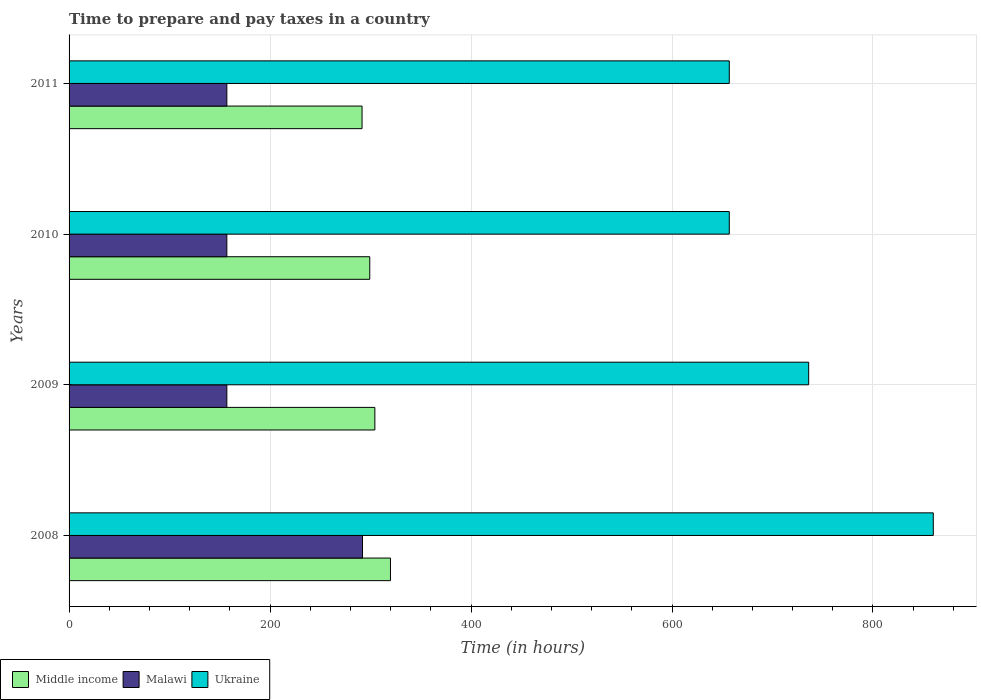Are the number of bars per tick equal to the number of legend labels?
Offer a terse response. Yes. Are the number of bars on each tick of the Y-axis equal?
Your answer should be compact. Yes. How many bars are there on the 3rd tick from the top?
Provide a succinct answer. 3. How many bars are there on the 4th tick from the bottom?
Your answer should be very brief. 3. In how many cases, is the number of bars for a given year not equal to the number of legend labels?
Give a very brief answer. 0. What is the number of hours required to prepare and pay taxes in Middle income in 2011?
Your answer should be very brief. 291.56. Across all years, what is the maximum number of hours required to prepare and pay taxes in Ukraine?
Offer a very short reply. 860. Across all years, what is the minimum number of hours required to prepare and pay taxes in Malawi?
Provide a succinct answer. 157. In which year was the number of hours required to prepare and pay taxes in Middle income minimum?
Offer a terse response. 2011. What is the total number of hours required to prepare and pay taxes in Ukraine in the graph?
Your answer should be compact. 2910. What is the difference between the number of hours required to prepare and pay taxes in Ukraine in 2008 and that in 2011?
Keep it short and to the point. 203. What is the difference between the number of hours required to prepare and pay taxes in Ukraine in 2009 and the number of hours required to prepare and pay taxes in Middle income in 2008?
Provide a succinct answer. 416.17. What is the average number of hours required to prepare and pay taxes in Middle income per year?
Your answer should be compact. 303.73. In the year 2008, what is the difference between the number of hours required to prepare and pay taxes in Middle income and number of hours required to prepare and pay taxes in Ukraine?
Offer a terse response. -540.17. What is the ratio of the number of hours required to prepare and pay taxes in Malawi in 2010 to that in 2011?
Offer a terse response. 1. Is the number of hours required to prepare and pay taxes in Middle income in 2008 less than that in 2011?
Your answer should be compact. No. What is the difference between the highest and the second highest number of hours required to prepare and pay taxes in Malawi?
Your answer should be compact. 135. What is the difference between the highest and the lowest number of hours required to prepare and pay taxes in Middle income?
Your answer should be compact. 28.28. In how many years, is the number of hours required to prepare and pay taxes in Middle income greater than the average number of hours required to prepare and pay taxes in Middle income taken over all years?
Offer a terse response. 2. Is the sum of the number of hours required to prepare and pay taxes in Malawi in 2008 and 2010 greater than the maximum number of hours required to prepare and pay taxes in Middle income across all years?
Make the answer very short. Yes. What does the 1st bar from the top in 2011 represents?
Provide a short and direct response. Ukraine. What does the 3rd bar from the bottom in 2008 represents?
Offer a terse response. Ukraine. Is it the case that in every year, the sum of the number of hours required to prepare and pay taxes in Middle income and number of hours required to prepare and pay taxes in Malawi is greater than the number of hours required to prepare and pay taxes in Ukraine?
Keep it short and to the point. No. How many years are there in the graph?
Offer a very short reply. 4. Are the values on the major ticks of X-axis written in scientific E-notation?
Your answer should be very brief. No. Does the graph contain any zero values?
Your answer should be compact. No. What is the title of the graph?
Ensure brevity in your answer.  Time to prepare and pay taxes in a country. What is the label or title of the X-axis?
Your response must be concise. Time (in hours). What is the Time (in hours) of Middle income in 2008?
Provide a succinct answer. 319.83. What is the Time (in hours) in Malawi in 2008?
Give a very brief answer. 292. What is the Time (in hours) of Ukraine in 2008?
Provide a short and direct response. 860. What is the Time (in hours) in Middle income in 2009?
Your answer should be compact. 304.31. What is the Time (in hours) of Malawi in 2009?
Offer a terse response. 157. What is the Time (in hours) in Ukraine in 2009?
Your response must be concise. 736. What is the Time (in hours) of Middle income in 2010?
Your answer should be very brief. 299.24. What is the Time (in hours) in Malawi in 2010?
Your answer should be very brief. 157. What is the Time (in hours) of Ukraine in 2010?
Provide a short and direct response. 657. What is the Time (in hours) of Middle income in 2011?
Provide a short and direct response. 291.56. What is the Time (in hours) of Malawi in 2011?
Keep it short and to the point. 157. What is the Time (in hours) in Ukraine in 2011?
Make the answer very short. 657. Across all years, what is the maximum Time (in hours) in Middle income?
Your response must be concise. 319.83. Across all years, what is the maximum Time (in hours) in Malawi?
Make the answer very short. 292. Across all years, what is the maximum Time (in hours) of Ukraine?
Give a very brief answer. 860. Across all years, what is the minimum Time (in hours) of Middle income?
Your answer should be very brief. 291.56. Across all years, what is the minimum Time (in hours) of Malawi?
Your answer should be compact. 157. Across all years, what is the minimum Time (in hours) of Ukraine?
Offer a terse response. 657. What is the total Time (in hours) of Middle income in the graph?
Your answer should be compact. 1214.93. What is the total Time (in hours) of Malawi in the graph?
Your response must be concise. 763. What is the total Time (in hours) of Ukraine in the graph?
Provide a short and direct response. 2910. What is the difference between the Time (in hours) of Middle income in 2008 and that in 2009?
Provide a short and direct response. 15.53. What is the difference between the Time (in hours) of Malawi in 2008 and that in 2009?
Offer a very short reply. 135. What is the difference between the Time (in hours) of Ukraine in 2008 and that in 2009?
Your response must be concise. 124. What is the difference between the Time (in hours) in Middle income in 2008 and that in 2010?
Your answer should be very brief. 20.59. What is the difference between the Time (in hours) of Malawi in 2008 and that in 2010?
Ensure brevity in your answer.  135. What is the difference between the Time (in hours) of Ukraine in 2008 and that in 2010?
Offer a very short reply. 203. What is the difference between the Time (in hours) in Middle income in 2008 and that in 2011?
Your answer should be very brief. 28.28. What is the difference between the Time (in hours) of Malawi in 2008 and that in 2011?
Your answer should be compact. 135. What is the difference between the Time (in hours) in Ukraine in 2008 and that in 2011?
Offer a very short reply. 203. What is the difference between the Time (in hours) of Middle income in 2009 and that in 2010?
Offer a very short reply. 5.07. What is the difference between the Time (in hours) of Ukraine in 2009 and that in 2010?
Provide a succinct answer. 79. What is the difference between the Time (in hours) of Middle income in 2009 and that in 2011?
Ensure brevity in your answer.  12.75. What is the difference between the Time (in hours) in Malawi in 2009 and that in 2011?
Ensure brevity in your answer.  0. What is the difference between the Time (in hours) in Ukraine in 2009 and that in 2011?
Provide a short and direct response. 79. What is the difference between the Time (in hours) in Middle income in 2010 and that in 2011?
Give a very brief answer. 7.68. What is the difference between the Time (in hours) of Middle income in 2008 and the Time (in hours) of Malawi in 2009?
Give a very brief answer. 162.83. What is the difference between the Time (in hours) in Middle income in 2008 and the Time (in hours) in Ukraine in 2009?
Provide a succinct answer. -416.17. What is the difference between the Time (in hours) of Malawi in 2008 and the Time (in hours) of Ukraine in 2009?
Provide a succinct answer. -444. What is the difference between the Time (in hours) of Middle income in 2008 and the Time (in hours) of Malawi in 2010?
Offer a very short reply. 162.83. What is the difference between the Time (in hours) in Middle income in 2008 and the Time (in hours) in Ukraine in 2010?
Your answer should be compact. -337.17. What is the difference between the Time (in hours) of Malawi in 2008 and the Time (in hours) of Ukraine in 2010?
Offer a very short reply. -365. What is the difference between the Time (in hours) of Middle income in 2008 and the Time (in hours) of Malawi in 2011?
Your response must be concise. 162.83. What is the difference between the Time (in hours) in Middle income in 2008 and the Time (in hours) in Ukraine in 2011?
Keep it short and to the point. -337.17. What is the difference between the Time (in hours) of Malawi in 2008 and the Time (in hours) of Ukraine in 2011?
Provide a succinct answer. -365. What is the difference between the Time (in hours) of Middle income in 2009 and the Time (in hours) of Malawi in 2010?
Make the answer very short. 147.31. What is the difference between the Time (in hours) in Middle income in 2009 and the Time (in hours) in Ukraine in 2010?
Your answer should be very brief. -352.69. What is the difference between the Time (in hours) in Malawi in 2009 and the Time (in hours) in Ukraine in 2010?
Offer a terse response. -500. What is the difference between the Time (in hours) of Middle income in 2009 and the Time (in hours) of Malawi in 2011?
Keep it short and to the point. 147.31. What is the difference between the Time (in hours) of Middle income in 2009 and the Time (in hours) of Ukraine in 2011?
Your answer should be very brief. -352.69. What is the difference between the Time (in hours) of Malawi in 2009 and the Time (in hours) of Ukraine in 2011?
Offer a terse response. -500. What is the difference between the Time (in hours) in Middle income in 2010 and the Time (in hours) in Malawi in 2011?
Provide a succinct answer. 142.24. What is the difference between the Time (in hours) in Middle income in 2010 and the Time (in hours) in Ukraine in 2011?
Your answer should be compact. -357.76. What is the difference between the Time (in hours) of Malawi in 2010 and the Time (in hours) of Ukraine in 2011?
Provide a succinct answer. -500. What is the average Time (in hours) in Middle income per year?
Ensure brevity in your answer.  303.73. What is the average Time (in hours) in Malawi per year?
Give a very brief answer. 190.75. What is the average Time (in hours) in Ukraine per year?
Give a very brief answer. 727.5. In the year 2008, what is the difference between the Time (in hours) of Middle income and Time (in hours) of Malawi?
Provide a short and direct response. 27.83. In the year 2008, what is the difference between the Time (in hours) in Middle income and Time (in hours) in Ukraine?
Ensure brevity in your answer.  -540.17. In the year 2008, what is the difference between the Time (in hours) in Malawi and Time (in hours) in Ukraine?
Offer a very short reply. -568. In the year 2009, what is the difference between the Time (in hours) in Middle income and Time (in hours) in Malawi?
Provide a short and direct response. 147.31. In the year 2009, what is the difference between the Time (in hours) of Middle income and Time (in hours) of Ukraine?
Give a very brief answer. -431.69. In the year 2009, what is the difference between the Time (in hours) of Malawi and Time (in hours) of Ukraine?
Offer a very short reply. -579. In the year 2010, what is the difference between the Time (in hours) of Middle income and Time (in hours) of Malawi?
Ensure brevity in your answer.  142.24. In the year 2010, what is the difference between the Time (in hours) in Middle income and Time (in hours) in Ukraine?
Offer a very short reply. -357.76. In the year 2010, what is the difference between the Time (in hours) of Malawi and Time (in hours) of Ukraine?
Give a very brief answer. -500. In the year 2011, what is the difference between the Time (in hours) of Middle income and Time (in hours) of Malawi?
Provide a short and direct response. 134.56. In the year 2011, what is the difference between the Time (in hours) in Middle income and Time (in hours) in Ukraine?
Provide a short and direct response. -365.44. In the year 2011, what is the difference between the Time (in hours) of Malawi and Time (in hours) of Ukraine?
Offer a terse response. -500. What is the ratio of the Time (in hours) of Middle income in 2008 to that in 2009?
Make the answer very short. 1.05. What is the ratio of the Time (in hours) in Malawi in 2008 to that in 2009?
Make the answer very short. 1.86. What is the ratio of the Time (in hours) of Ukraine in 2008 to that in 2009?
Offer a terse response. 1.17. What is the ratio of the Time (in hours) in Middle income in 2008 to that in 2010?
Provide a short and direct response. 1.07. What is the ratio of the Time (in hours) of Malawi in 2008 to that in 2010?
Offer a terse response. 1.86. What is the ratio of the Time (in hours) in Ukraine in 2008 to that in 2010?
Provide a succinct answer. 1.31. What is the ratio of the Time (in hours) in Middle income in 2008 to that in 2011?
Give a very brief answer. 1.1. What is the ratio of the Time (in hours) of Malawi in 2008 to that in 2011?
Your answer should be compact. 1.86. What is the ratio of the Time (in hours) of Ukraine in 2008 to that in 2011?
Make the answer very short. 1.31. What is the ratio of the Time (in hours) of Middle income in 2009 to that in 2010?
Your answer should be compact. 1.02. What is the ratio of the Time (in hours) in Malawi in 2009 to that in 2010?
Provide a short and direct response. 1. What is the ratio of the Time (in hours) in Ukraine in 2009 to that in 2010?
Provide a succinct answer. 1.12. What is the ratio of the Time (in hours) in Middle income in 2009 to that in 2011?
Your answer should be compact. 1.04. What is the ratio of the Time (in hours) of Ukraine in 2009 to that in 2011?
Offer a very short reply. 1.12. What is the ratio of the Time (in hours) in Middle income in 2010 to that in 2011?
Keep it short and to the point. 1.03. What is the ratio of the Time (in hours) of Malawi in 2010 to that in 2011?
Make the answer very short. 1. What is the difference between the highest and the second highest Time (in hours) in Middle income?
Offer a very short reply. 15.53. What is the difference between the highest and the second highest Time (in hours) of Malawi?
Provide a succinct answer. 135. What is the difference between the highest and the second highest Time (in hours) in Ukraine?
Your response must be concise. 124. What is the difference between the highest and the lowest Time (in hours) in Middle income?
Offer a very short reply. 28.28. What is the difference between the highest and the lowest Time (in hours) of Malawi?
Your response must be concise. 135. What is the difference between the highest and the lowest Time (in hours) in Ukraine?
Ensure brevity in your answer.  203. 